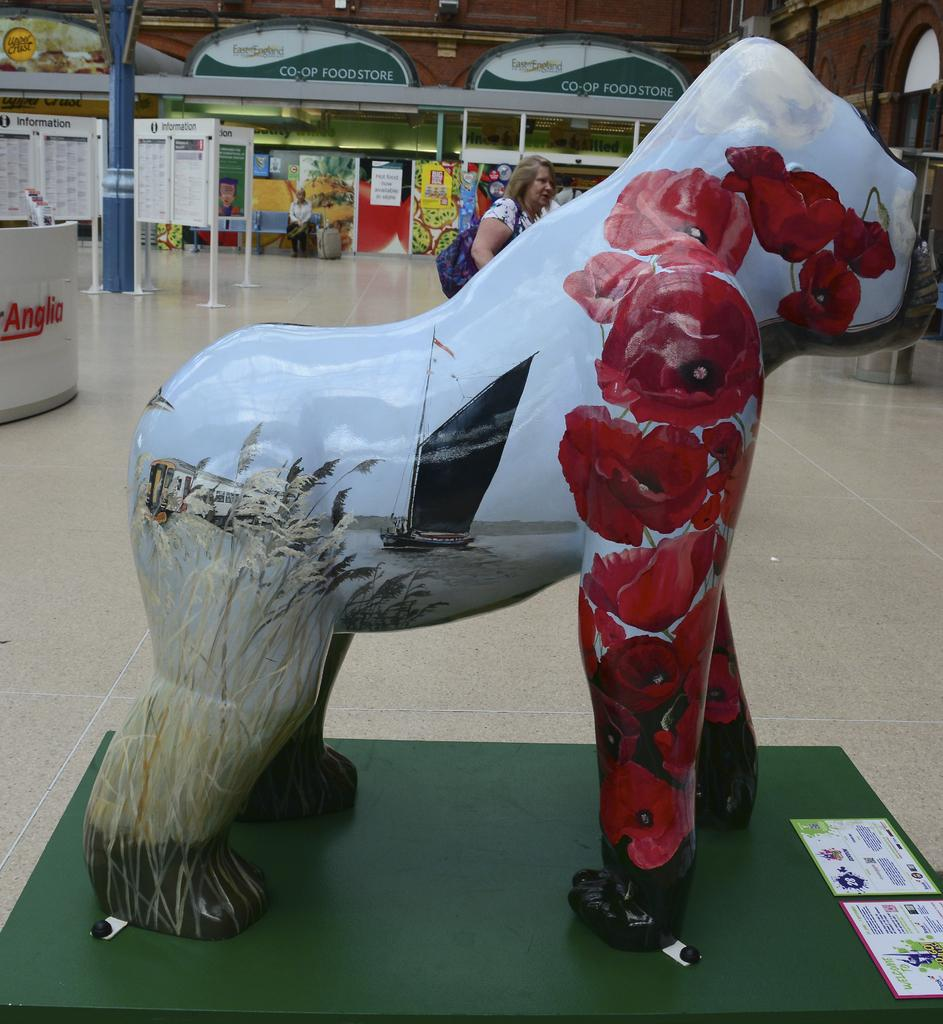What type of location is depicted in the image? The image shows the inside view of a mall. Can you describe the people in the image? There are people in the image, but their specific actions or appearances are not mentioned in the provided facts. What kind of artwork is present in the image? There is a sculpture in the image. What type of signage is visible in the image? There are boards with text in the image. What type of furniture is visible in the image? There is a wooden table in the image. What other objects can be seen in the image? There are other objects in the image, but their specific details are not mentioned in the provided facts. What type of current is flowing through the wooden table in the image? There is no mention of any current flowing through the wooden table in the image. 